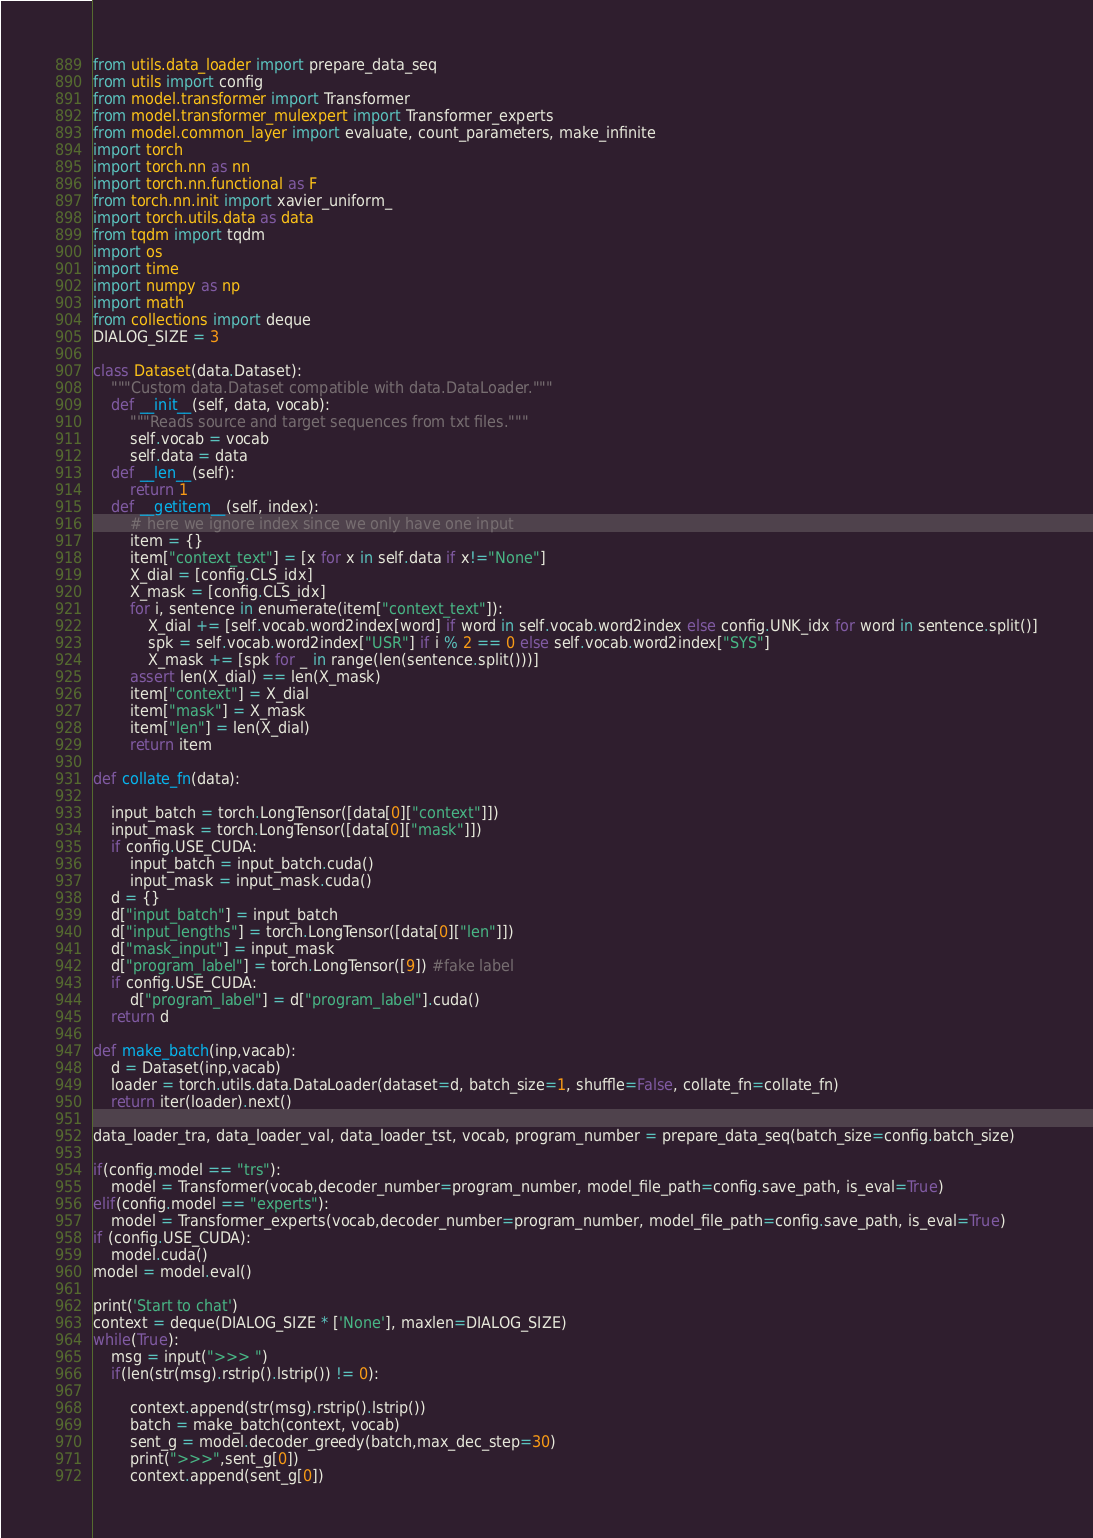Convert code to text. <code><loc_0><loc_0><loc_500><loc_500><_Python_>from utils.data_loader import prepare_data_seq
from utils import config
from model.transformer import Transformer
from model.transformer_mulexpert import Transformer_experts
from model.common_layer import evaluate, count_parameters, make_infinite
import torch
import torch.nn as nn
import torch.nn.functional as F
from torch.nn.init import xavier_uniform_
import torch.utils.data as data
from tqdm import tqdm
import os
import time 
import numpy as np
import math
from collections import deque
DIALOG_SIZE = 3

class Dataset(data.Dataset):
    """Custom data.Dataset compatible with data.DataLoader."""
    def __init__(self, data, vocab):
        """Reads source and target sequences from txt files."""
        self.vocab = vocab
        self.data = data
    def __len__(self):
        return 1
    def __getitem__(self, index):
        # here we ignore index since we only have one input
        item = {}
        item["context_text"] = [x for x in self.data if x!="None"]
        X_dial = [config.CLS_idx]
        X_mask = [config.CLS_idx]
        for i, sentence in enumerate(item["context_text"]):
            X_dial += [self.vocab.word2index[word] if word in self.vocab.word2index else config.UNK_idx for word in sentence.split()]
            spk = self.vocab.word2index["USR"] if i % 2 == 0 else self.vocab.word2index["SYS"]
            X_mask += [spk for _ in range(len(sentence.split()))]
        assert len(X_dial) == len(X_mask)
        item["context"] = X_dial
        item["mask"] = X_mask
        item["len"] = len(X_dial)
        return item

def collate_fn(data):
    
    input_batch = torch.LongTensor([data[0]["context"]])
    input_mask = torch.LongTensor([data[0]["mask"]])
    if config.USE_CUDA:
        input_batch = input_batch.cuda()
        input_mask = input_mask.cuda()
    d = {}
    d["input_batch"] = input_batch
    d["input_lengths"] = torch.LongTensor([data[0]["len"]])
    d["mask_input"] = input_mask
    d["program_label"] = torch.LongTensor([9]) #fake label
    if config.USE_CUDA:
        d["program_label"] = d["program_label"].cuda()
    return d 

def make_batch(inp,vacab):
    d = Dataset(inp,vacab)
    loader = torch.utils.data.DataLoader(dataset=d, batch_size=1, shuffle=False, collate_fn=collate_fn)
    return iter(loader).next()

data_loader_tra, data_loader_val, data_loader_tst, vocab, program_number = prepare_data_seq(batch_size=config.batch_size)

if(config.model == "trs"):
    model = Transformer(vocab,decoder_number=program_number, model_file_path=config.save_path, is_eval=True)
elif(config.model == "experts"):
    model = Transformer_experts(vocab,decoder_number=program_number, model_file_path=config.save_path, is_eval=True)
if (config.USE_CUDA):
    model.cuda()
model = model.eval()

print('Start to chat')
context = deque(DIALOG_SIZE * ['None'], maxlen=DIALOG_SIZE)
while(True):
    msg = input(">>> ")
    if(len(str(msg).rstrip().lstrip()) != 0):

        context.append(str(msg).rstrip().lstrip())
        batch = make_batch(context, vocab)
        sent_g = model.decoder_greedy(batch,max_dec_step=30)
        print(">>>",sent_g[0])
        context.append(sent_g[0])</code> 